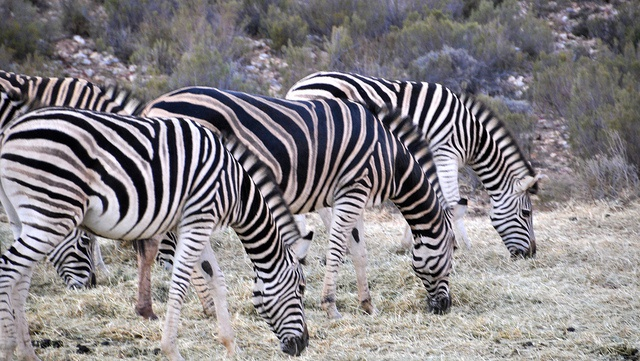Describe the objects in this image and their specific colors. I can see zebra in gray, lavender, black, and darkgray tones, zebra in gray, black, darkgray, and lightgray tones, zebra in gray, lavender, black, and darkgray tones, zebra in gray, black, darkgray, and lightgray tones, and zebra in gray, darkgray, black, and lightgray tones in this image. 